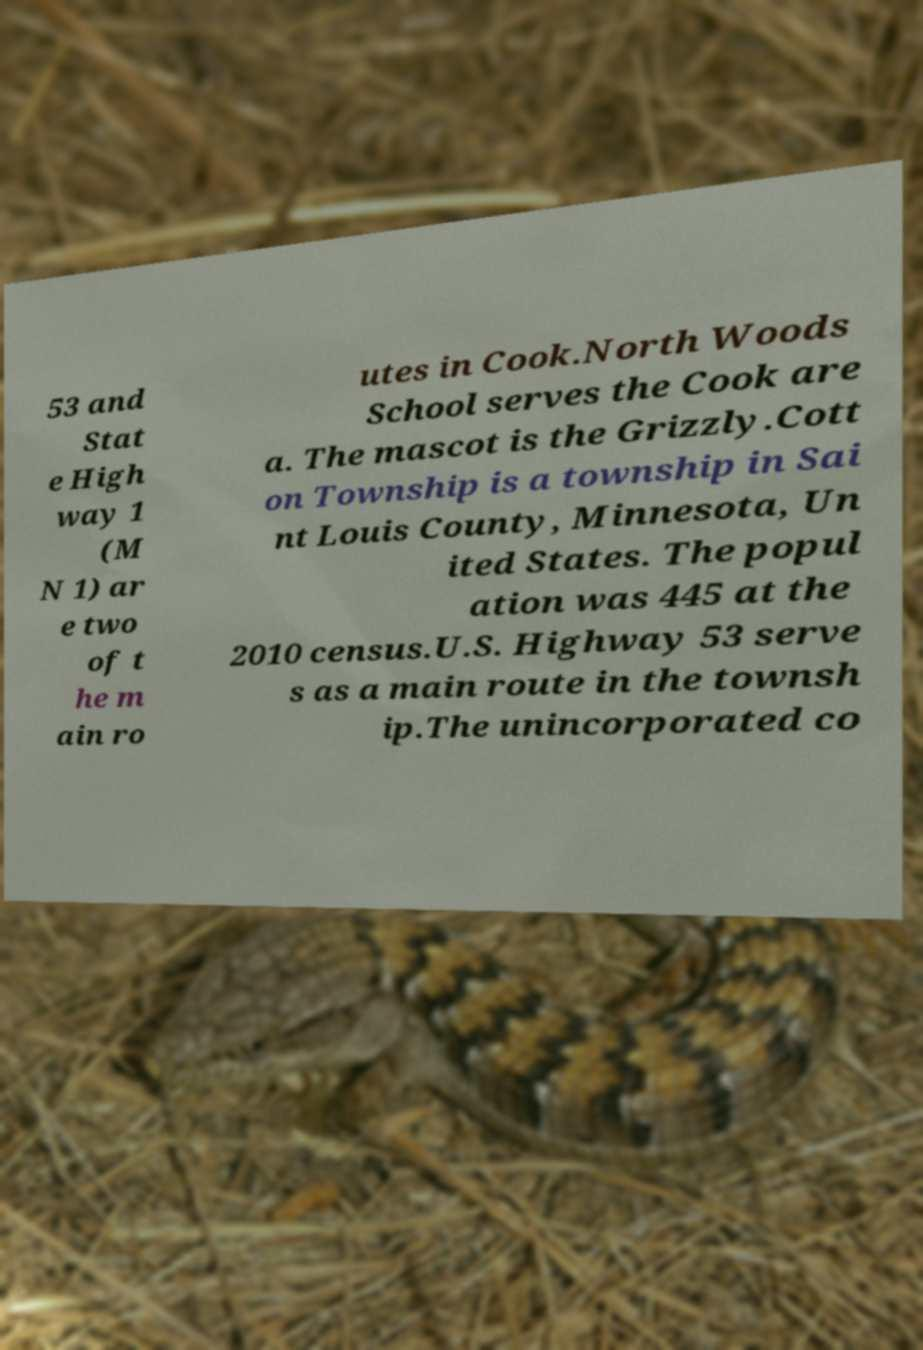Please read and relay the text visible in this image. What does it say? 53 and Stat e High way 1 (M N 1) ar e two of t he m ain ro utes in Cook.North Woods School serves the Cook are a. The mascot is the Grizzly.Cott on Township is a township in Sai nt Louis County, Minnesota, Un ited States. The popul ation was 445 at the 2010 census.U.S. Highway 53 serve s as a main route in the townsh ip.The unincorporated co 